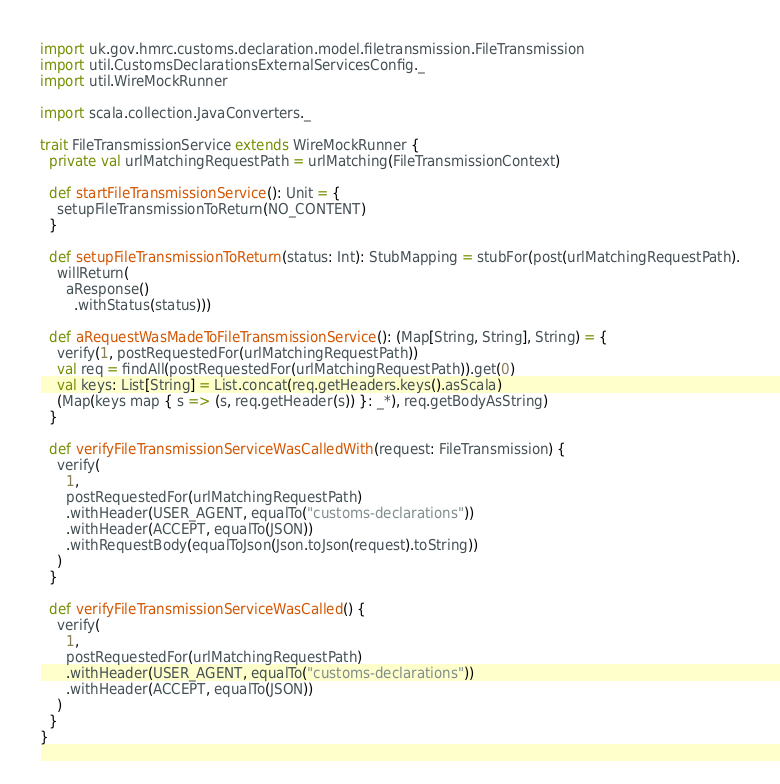<code> <loc_0><loc_0><loc_500><loc_500><_Scala_>import uk.gov.hmrc.customs.declaration.model.filetransmission.FileTransmission
import util.CustomsDeclarationsExternalServicesConfig._
import util.WireMockRunner

import scala.collection.JavaConverters._

trait FileTransmissionService extends WireMockRunner {
  private val urlMatchingRequestPath = urlMatching(FileTransmissionContext)

  def startFileTransmissionService(): Unit = {
    setupFileTransmissionToReturn(NO_CONTENT)
  }

  def setupFileTransmissionToReturn(status: Int): StubMapping = stubFor(post(urlMatchingRequestPath).
    willReturn(
      aResponse()
        .withStatus(status)))

  def aRequestWasMadeToFileTransmissionService(): (Map[String, String], String) = {
    verify(1, postRequestedFor(urlMatchingRequestPath))
    val req = findAll(postRequestedFor(urlMatchingRequestPath)).get(0)
    val keys: List[String] = List.concat(req.getHeaders.keys().asScala)
    (Map(keys map { s => (s, req.getHeader(s)) }: _*), req.getBodyAsString)
  }

  def verifyFileTransmissionServiceWasCalledWith(request: FileTransmission) {
    verify(
      1,
      postRequestedFor(urlMatchingRequestPath)
      .withHeader(USER_AGENT, equalTo("customs-declarations"))
      .withHeader(ACCEPT, equalTo(JSON))
      .withRequestBody(equalToJson(Json.toJson(request).toString))
    )
  }

  def verifyFileTransmissionServiceWasCalled() {
    verify(
      1,
      postRequestedFor(urlMatchingRequestPath)
      .withHeader(USER_AGENT, equalTo("customs-declarations"))
      .withHeader(ACCEPT, equalTo(JSON))
    )
  }
}
</code> 